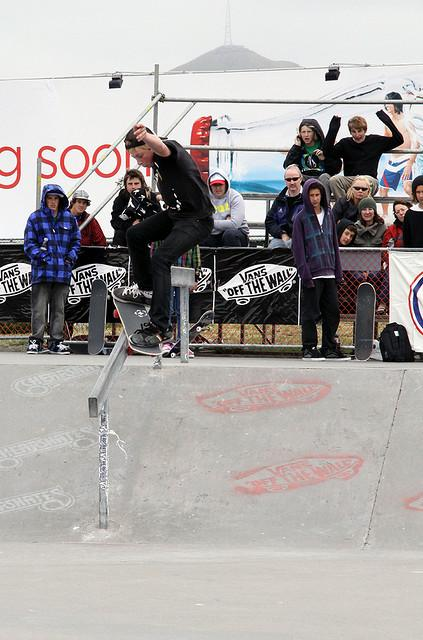What is he doing hanging from the board? Please explain your reasoning. balancing. A person is on a skateboard performing a jump. people have to balance on skateboards to avoid falling. 